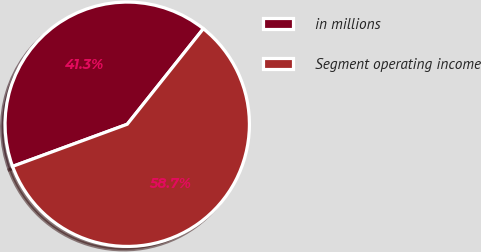Convert chart. <chart><loc_0><loc_0><loc_500><loc_500><pie_chart><fcel>in millions<fcel>Segment operating income<nl><fcel>41.31%<fcel>58.69%<nl></chart> 